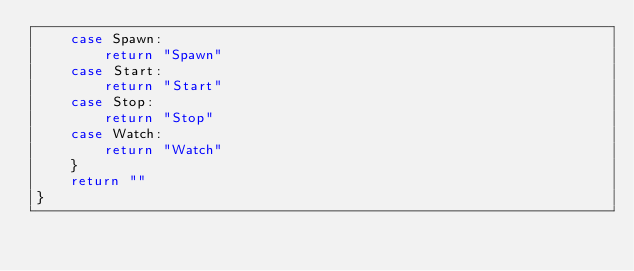Convert code to text. <code><loc_0><loc_0><loc_500><loc_500><_Go_>	case Spawn:
		return "Spawn"
	case Start:
		return "Start"
	case Stop:
		return "Stop"
	case Watch:
		return "Watch"
	}
	return ""
}
</code> 